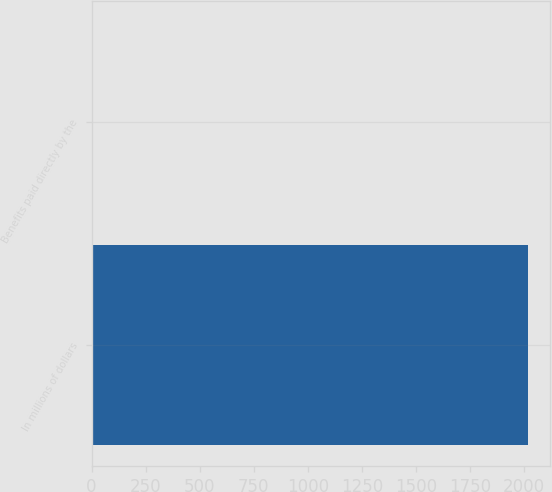Convert chart. <chart><loc_0><loc_0><loc_500><loc_500><bar_chart><fcel>In millions of dollars<fcel>Benefits paid directly by the<nl><fcel>2019<fcel>6<nl></chart> 